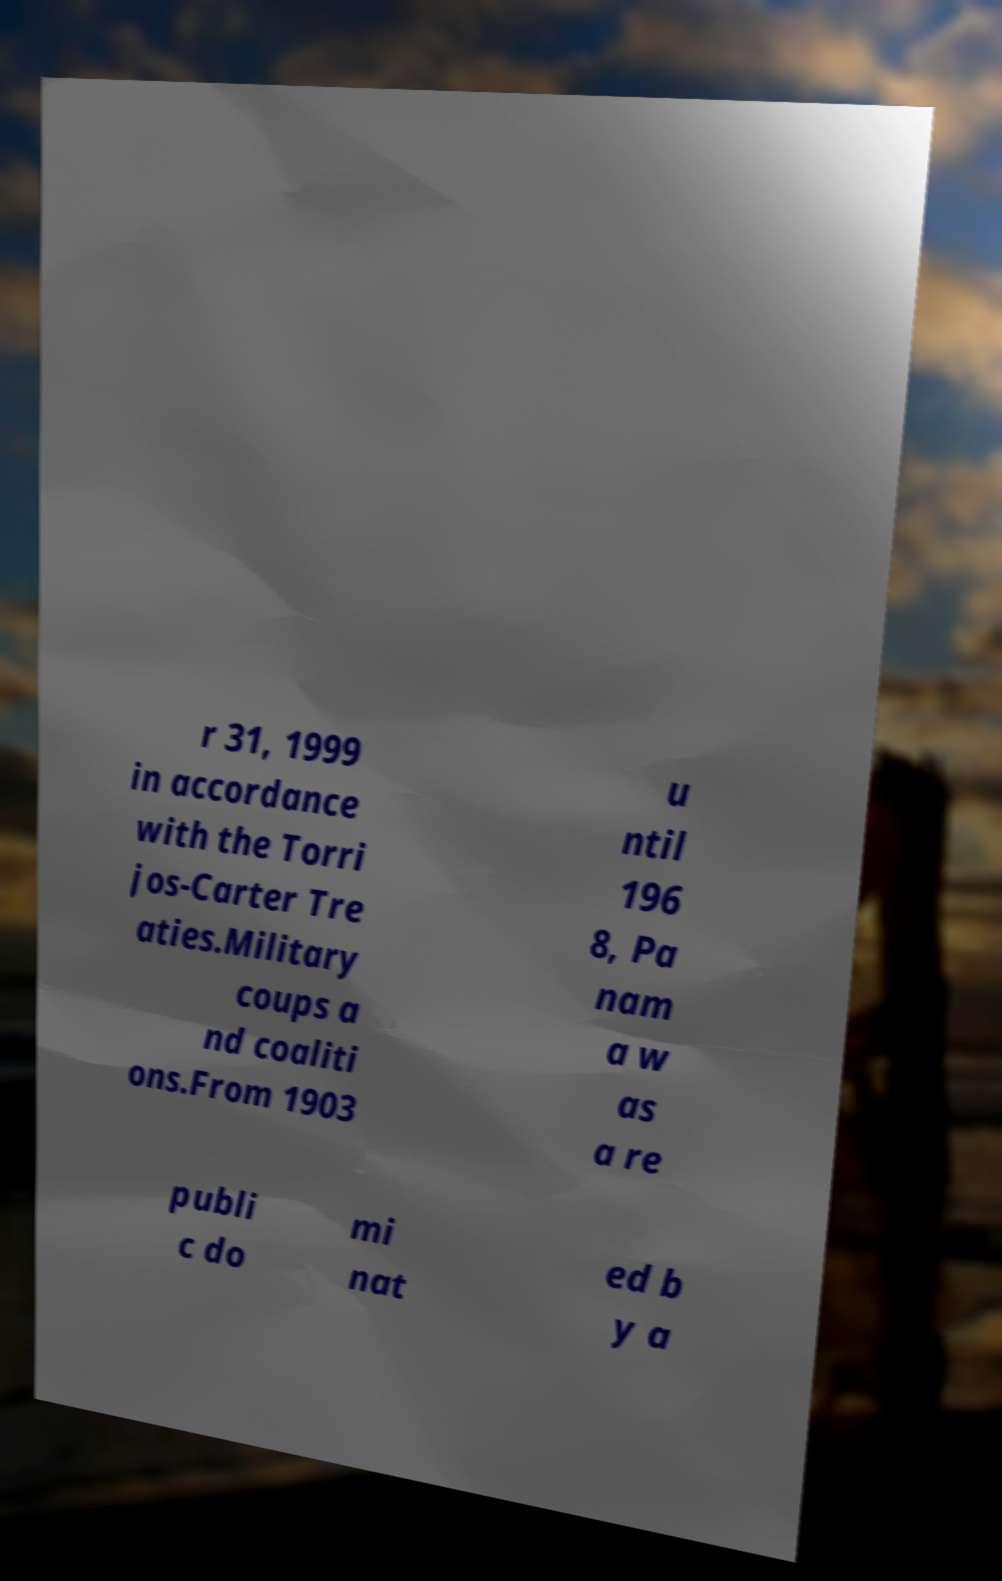Could you extract and type out the text from this image? r 31, 1999 in accordance with the Torri jos-Carter Tre aties.Military coups a nd coaliti ons.From 1903 u ntil 196 8, Pa nam a w as a re publi c do mi nat ed b y a 